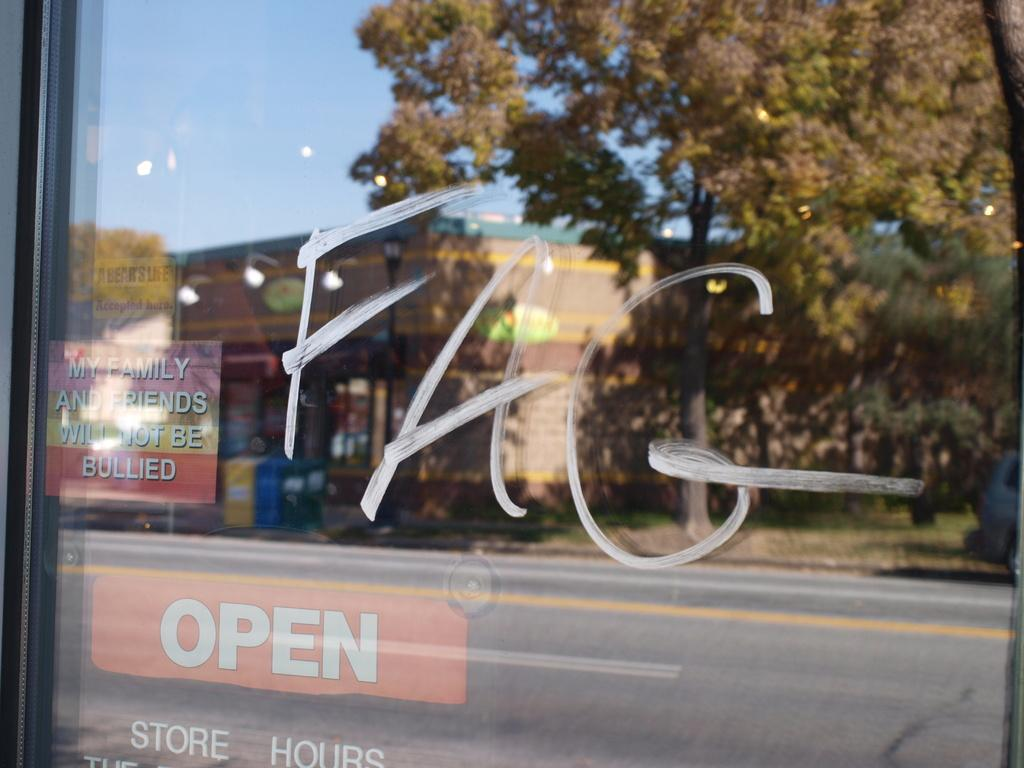What type of surface is visible in the image? There is a glass surface in the image. What can be seen in the reflection on the glass surface? The reflection of trees, buildings, the road, and the sky are visible on the glass surface. How many dolls are sitting on the grain in the image? There are no dolls or grain present in the image; it features a glass surface with various reflections. 